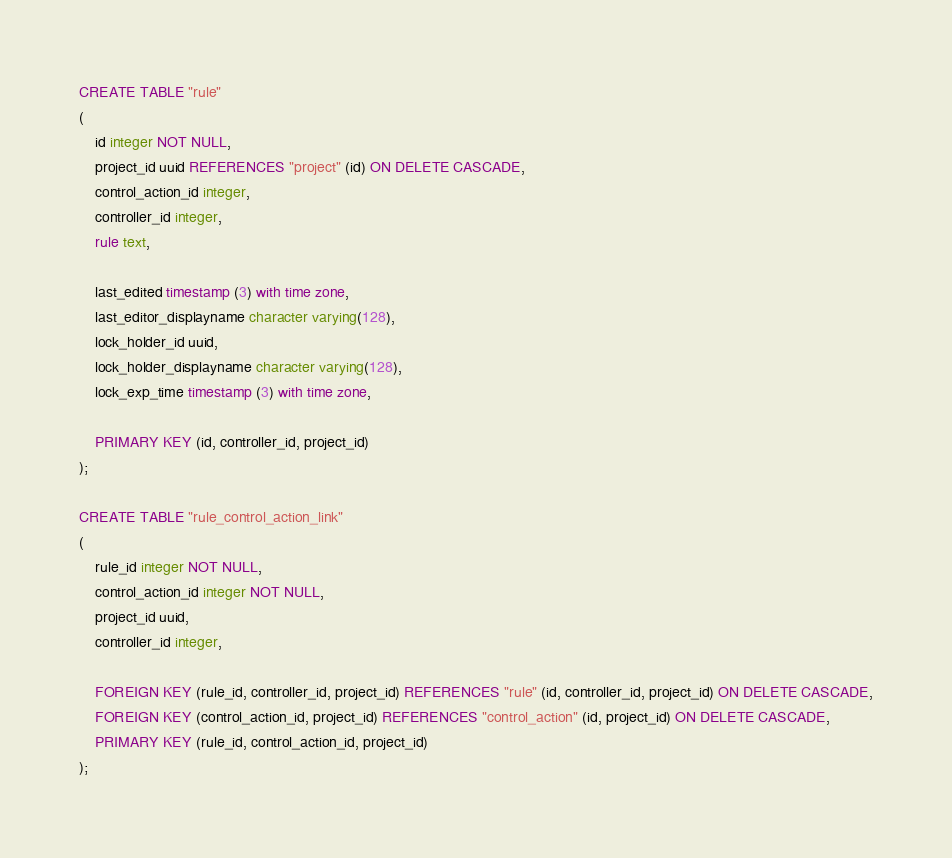<code> <loc_0><loc_0><loc_500><loc_500><_SQL_>
CREATE TABLE "rule"
(
    id integer NOT NULL,
    project_id uuid REFERENCES "project" (id) ON DELETE CASCADE,
    control_action_id integer,
    controller_id integer,
    rule text,

    last_edited timestamp (3) with time zone,
    last_editor_displayname character varying(128),
    lock_holder_id uuid,
    lock_holder_displayname character varying(128),
    lock_exp_time timestamp (3) with time zone,

    PRIMARY KEY (id, controller_id, project_id)
);

CREATE TABLE "rule_control_action_link"
(
    rule_id integer NOT NULL,
    control_action_id integer NOT NULL,
    project_id uuid,
    controller_id integer,

    FOREIGN KEY (rule_id, controller_id, project_id) REFERENCES "rule" (id, controller_id, project_id) ON DELETE CASCADE,
    FOREIGN KEY (control_action_id, project_id) REFERENCES "control_action" (id, project_id) ON DELETE CASCADE,
    PRIMARY KEY (rule_id, control_action_id, project_id)
);
</code> 